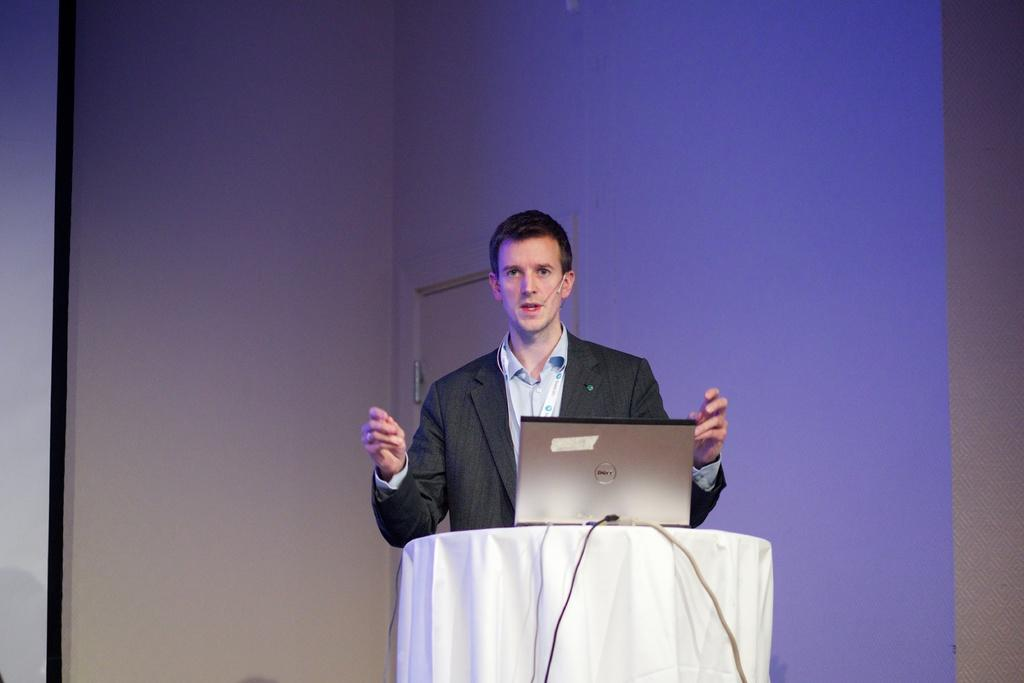Who is present in the image? There is a man in the image. What is the man wearing on his upper body? The man is wearing a blazer and a shirt. What object can be seen in the image that is typically used for cleaning or covering surfaces? There is a white cloth in the image. What type of technology is visible in the image? There is a laptop in the image. What other detail can be observed in the image? There are wires visible in the image. Where are the ducks sitting in the image? There are no ducks present in the image. What type of furniture can be seen in the image? The provided facts do not mention any furniture in the image. 